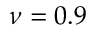<formula> <loc_0><loc_0><loc_500><loc_500>\nu = 0 . 9</formula> 